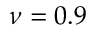<formula> <loc_0><loc_0><loc_500><loc_500>\nu = 0 . 9</formula> 